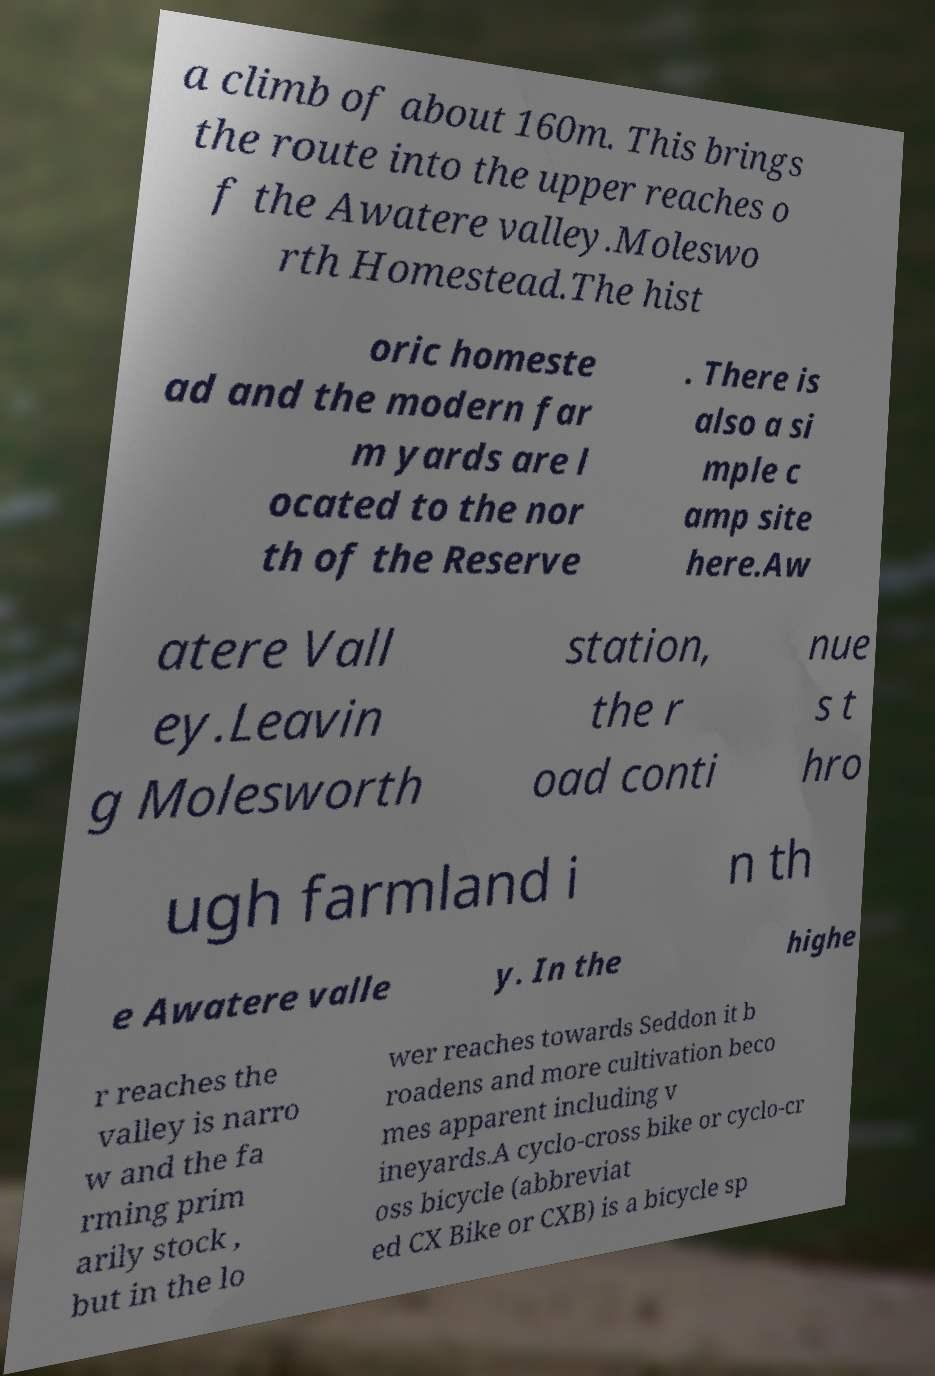Could you extract and type out the text from this image? a climb of about 160m. This brings the route into the upper reaches o f the Awatere valley.Moleswo rth Homestead.The hist oric homeste ad and the modern far m yards are l ocated to the nor th of the Reserve . There is also a si mple c amp site here.Aw atere Vall ey.Leavin g Molesworth station, the r oad conti nue s t hro ugh farmland i n th e Awatere valle y. In the highe r reaches the valley is narro w and the fa rming prim arily stock , but in the lo wer reaches towards Seddon it b roadens and more cultivation beco mes apparent including v ineyards.A cyclo-cross bike or cyclo-cr oss bicycle (abbreviat ed CX Bike or CXB) is a bicycle sp 